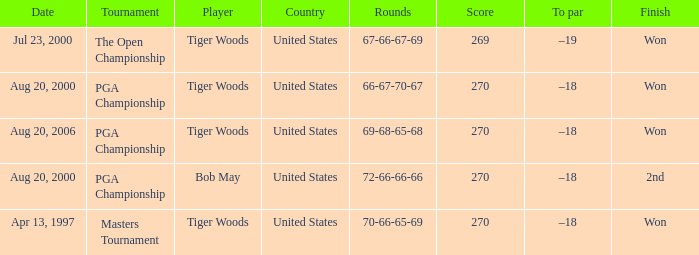What country hosts the tournament the open championship? United States. 